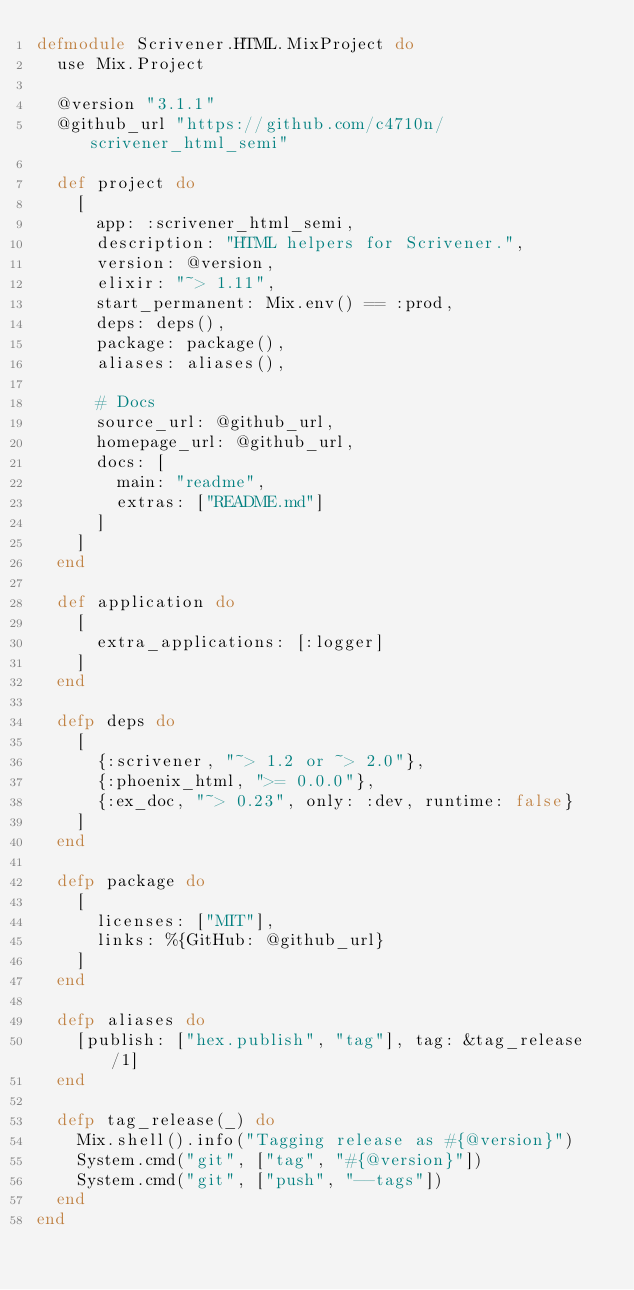Convert code to text. <code><loc_0><loc_0><loc_500><loc_500><_Elixir_>defmodule Scrivener.HTML.MixProject do
  use Mix.Project

  @version "3.1.1"
  @github_url "https://github.com/c4710n/scrivener_html_semi"

  def project do
    [
      app: :scrivener_html_semi,
      description: "HTML helpers for Scrivener.",
      version: @version,
      elixir: "~> 1.11",
      start_permanent: Mix.env() == :prod,
      deps: deps(),
      package: package(),
      aliases: aliases(),

      # Docs
      source_url: @github_url,
      homepage_url: @github_url,
      docs: [
        main: "readme",
        extras: ["README.md"]
      ]
    ]
  end

  def application do
    [
      extra_applications: [:logger]
    ]
  end

  defp deps do
    [
      {:scrivener, "~> 1.2 or ~> 2.0"},
      {:phoenix_html, ">= 0.0.0"},
      {:ex_doc, "~> 0.23", only: :dev, runtime: false}
    ]
  end

  defp package do
    [
      licenses: ["MIT"],
      links: %{GitHub: @github_url}
    ]
  end

  defp aliases do
    [publish: ["hex.publish", "tag"], tag: &tag_release/1]
  end

  defp tag_release(_) do
    Mix.shell().info("Tagging release as #{@version}")
    System.cmd("git", ["tag", "#{@version}"])
    System.cmd("git", ["push", "--tags"])
  end
end
</code> 